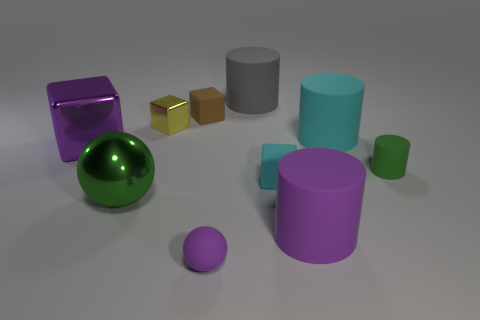Subtract all tiny cylinders. How many cylinders are left? 3 Subtract 1 blocks. How many blocks are left? 3 Subtract all gray blocks. Subtract all blue cylinders. How many blocks are left? 4 Subtract all balls. How many objects are left? 8 Add 4 cyan rubber things. How many cyan rubber things are left? 6 Add 8 metallic spheres. How many metallic spheres exist? 9 Subtract 0 green cubes. How many objects are left? 10 Subtract all rubber balls. Subtract all big things. How many objects are left? 4 